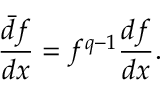Convert formula to latex. <formula><loc_0><loc_0><loc_500><loc_500>\frac { \bar { d } f } { d x } = f ^ { q - 1 } \frac { d f } { d x } .</formula> 